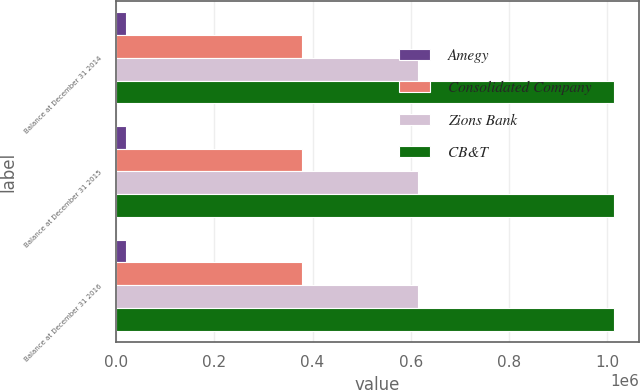Convert chart. <chart><loc_0><loc_0><loc_500><loc_500><stacked_bar_chart><ecel><fcel>Balance at December 31 2014<fcel>Balance at December 31 2015<fcel>Balance at December 31 2016<nl><fcel>Amegy<fcel>19514<fcel>19514<fcel>19514<nl><fcel>Consolidated Company<fcel>379024<fcel>379024<fcel>379024<nl><fcel>Zions Bank<fcel>615591<fcel>615591<fcel>615591<nl><fcel>CB&T<fcel>1.01413e+06<fcel>1.01413e+06<fcel>1.01413e+06<nl></chart> 